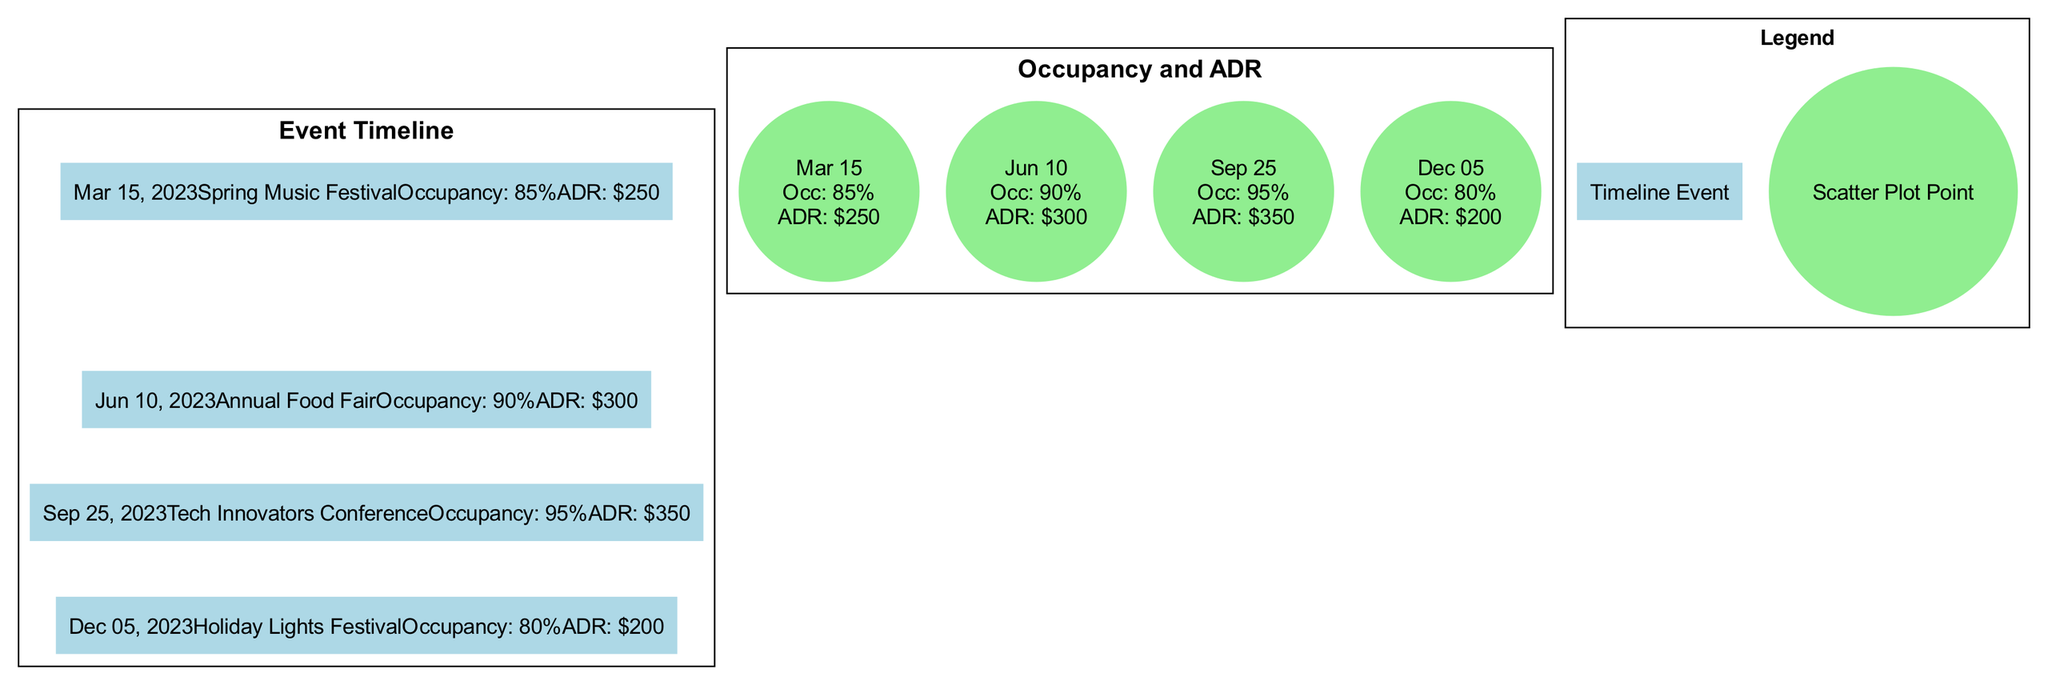What event occurred on June 10, 2023? The timeline indicates that the event on June 10, 2023, is the "Annual Food Fair."
Answer: Annual Food Fair What was the average daily rate during the Tech Innovators Conference? According to the scatter plot data, the average daily rate during the Tech Innovators Conference on September 25, 2023, was $350.
Answer: $350 What was the occupancy rate during the Spring Music Festival? Based on the timeline, the occupancy rate during the Spring Music Festival on March 15, 2023, was 85%.
Answer: 85% Which event had the highest occupancy rate and what was it? By comparing the occupancy rates listed on the timeline, the Tech Innovators Conference on September 25, 2023, had the highest occupancy rate at 95%.
Answer: Tech Innovators Conference How many events are displayed on the timeline? The timeline contains a total of four events listed sequentially.
Answer: 4 What was the impact on average daily rate during the Holiday Lights Festival? The data in the timeline shows that during the Holiday Lights Festival on December 5, 2023, the average daily rate was $200.
Answer: $200 What is the trend in average daily rates from March to September 2023? Analyzing the scatter plot data from March (average daily rate of $250) to September (average daily rate of $350) reveals an increasing trend in average daily rates.
Answer: Increasing Was there a decrease in occupancy rate from the Annual Food Fair to the Holiday Lights Festival? By comparing the occupancy rates, the Annual Food Fair had a rate of 90% and the Holiday Lights Festival had a rate of 80%, indicating a decrease of 10%.
Answer: Yes What was the occupancy rate on the same date as the Holiday Lights Festival? The Holiday Lights Festival occurred on December 5, 2023, with an occupancy rate recorded at 80%.
Answer: 80% 